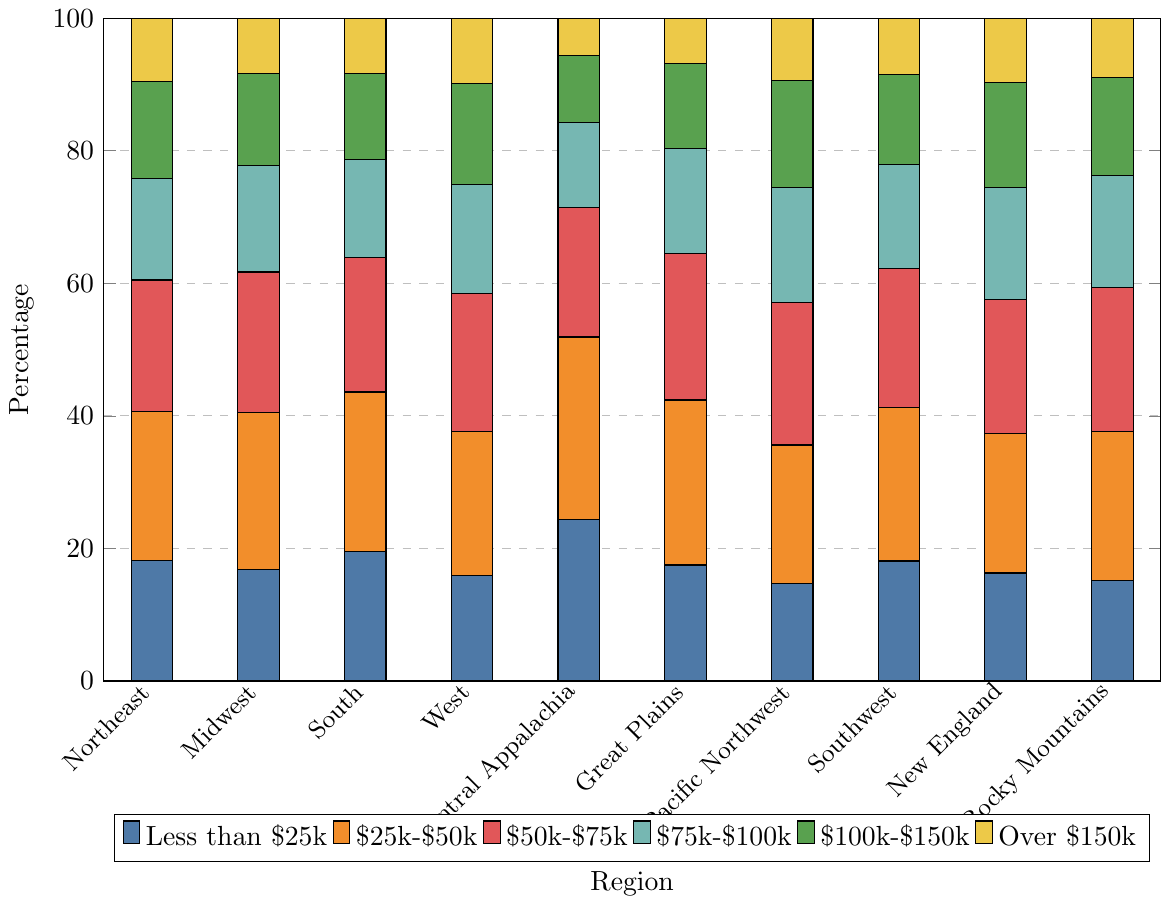Which region has the highest percentage of households earning less than $25,000? By observing the bar chart, we can see that the Central Appalachia region has the tallest bar for the "Less than $25k" category.
Answer: Central Appalachia Which two regions have the closest percentages for households earning $25,000-$50,000? Comparing the lengths of the orange bars for the "$25k-$50k" category, the Midwest (23.7%) and Rocky Mountains (22.4%) regions have the percentages that are closest to each other, though they are not exact matches.
Answer: Midwest and Rocky Mountains What is the average percentage of households earning over $150,000 in the western regions (Pacific Northwest and West)? First, identify the percentages for the "Over $150k" category in the Pacific Northwest (9.4%) and West (9.9%) regions. Then compute their average as (9.4 + 9.9) / 2.
Answer: 9.65% In which region is the percentage of households earning between $100,000 and $150,000 the lowest? By examining the green bars for the "$100k-$150k" category, we notice that the Central Appalachia region has the lowest value with 10.1%.
Answer: Central Appalachia Which region has a higher percentage of households earning between $75,000 and $100,000: the Northeast or the South? Check the red bars for the "$75k-$100k" category; the Northeast has 15.3% while the South has 14.8%. Therefore, the Northeast has a higher percentage.
Answer: Northeast What is the total percentage of households in the Northeast earning less than $75,000? Add the values of the Northeast for the "Less than $25k" (18.2%), "$25k-$50k" (22.5%), and "$50k-$75k" (19.8%) categories: 18.2 + 22.5 + 19.8 = 60.5%.
Answer: 60.5% How does the percentage of households earning between $50,000 and $75,000 in the Great Plains compare to those in the Midwest? The blue bars for the "$50k-$75k" category show that the Great Plains has 22.1% while the Midwest has 21.2%. The Great Plains has a slightly higher percentage.
Answer: Great Plains is higher What is the difference in the percentage of households earning less than $25,000 and those earning over $150,000 in New England? For New England, subtract the percentage for "Over $150k" (9.7%) from the percentage for "Less than $25k" (16.3%): 16.3 - 9.7 = 6.6%.
Answer: 6.6% Which region has the smallest range in income distribution percentages across all categories? The range is found by subtracting the smallest percentage from the largest within each region. Analyzing all the regions, the Rocky Mountains region has the smallest range, with the highest at 22.4% and the lowest at 8.9%, resulting in a range of 13.5%.
Answer: Rocky Mountains Based on the visual heights of the bars, which region appears to have the most evenly distributed household income levels? Observing the relative heights of the bars across all categories, the West region appears to have the most even distribution because the bars are relatively similar in height.
Answer: West 